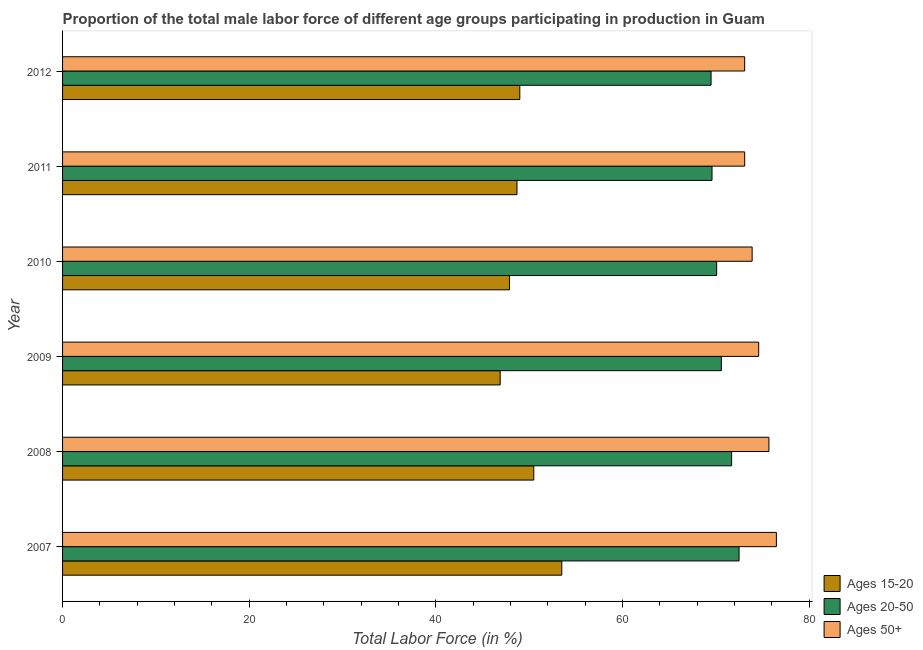How many groups of bars are there?
Your answer should be very brief. 6. Are the number of bars per tick equal to the number of legend labels?
Keep it short and to the point. Yes. Are the number of bars on each tick of the Y-axis equal?
Your answer should be very brief. Yes. How many bars are there on the 6th tick from the top?
Give a very brief answer. 3. How many bars are there on the 3rd tick from the bottom?
Make the answer very short. 3. What is the label of the 6th group of bars from the top?
Ensure brevity in your answer.  2007. In how many cases, is the number of bars for a given year not equal to the number of legend labels?
Offer a terse response. 0. What is the percentage of male labor force within the age group 15-20 in 2011?
Ensure brevity in your answer.  48.7. Across all years, what is the maximum percentage of male labor force above age 50?
Make the answer very short. 76.5. Across all years, what is the minimum percentage of male labor force within the age group 15-20?
Offer a terse response. 46.9. In which year was the percentage of male labor force within the age group 15-20 maximum?
Keep it short and to the point. 2007. What is the total percentage of male labor force above age 50 in the graph?
Your answer should be very brief. 446.9. What is the difference between the percentage of male labor force within the age group 20-50 in 2009 and the percentage of male labor force above age 50 in 2011?
Keep it short and to the point. -2.5. What is the average percentage of male labor force within the age group 20-50 per year?
Offer a very short reply. 70.67. In the year 2012, what is the difference between the percentage of male labor force within the age group 15-20 and percentage of male labor force within the age group 20-50?
Keep it short and to the point. -20.5. What is the ratio of the percentage of male labor force within the age group 20-50 in 2010 to that in 2011?
Provide a succinct answer. 1.01. Is the percentage of male labor force within the age group 15-20 in 2007 less than that in 2011?
Keep it short and to the point. No. Is the sum of the percentage of male labor force within the age group 15-20 in 2008 and 2010 greater than the maximum percentage of male labor force above age 50 across all years?
Your answer should be very brief. Yes. What does the 1st bar from the top in 2011 represents?
Your response must be concise. Ages 50+. What does the 3rd bar from the bottom in 2009 represents?
Ensure brevity in your answer.  Ages 50+. Is it the case that in every year, the sum of the percentage of male labor force within the age group 15-20 and percentage of male labor force within the age group 20-50 is greater than the percentage of male labor force above age 50?
Ensure brevity in your answer.  Yes. Are all the bars in the graph horizontal?
Make the answer very short. Yes. What is the difference between two consecutive major ticks on the X-axis?
Your response must be concise. 20. Are the values on the major ticks of X-axis written in scientific E-notation?
Make the answer very short. No. How many legend labels are there?
Keep it short and to the point. 3. How are the legend labels stacked?
Your answer should be compact. Vertical. What is the title of the graph?
Your answer should be very brief. Proportion of the total male labor force of different age groups participating in production in Guam. What is the Total Labor Force (in %) in Ages 15-20 in 2007?
Offer a very short reply. 53.5. What is the Total Labor Force (in %) of Ages 20-50 in 2007?
Offer a very short reply. 72.5. What is the Total Labor Force (in %) of Ages 50+ in 2007?
Provide a short and direct response. 76.5. What is the Total Labor Force (in %) in Ages 15-20 in 2008?
Offer a terse response. 50.5. What is the Total Labor Force (in %) of Ages 20-50 in 2008?
Provide a short and direct response. 71.7. What is the Total Labor Force (in %) in Ages 50+ in 2008?
Ensure brevity in your answer.  75.7. What is the Total Labor Force (in %) in Ages 15-20 in 2009?
Your response must be concise. 46.9. What is the Total Labor Force (in %) of Ages 20-50 in 2009?
Offer a terse response. 70.6. What is the Total Labor Force (in %) of Ages 50+ in 2009?
Your answer should be very brief. 74.6. What is the Total Labor Force (in %) in Ages 15-20 in 2010?
Offer a terse response. 47.9. What is the Total Labor Force (in %) of Ages 20-50 in 2010?
Keep it short and to the point. 70.1. What is the Total Labor Force (in %) of Ages 50+ in 2010?
Offer a very short reply. 73.9. What is the Total Labor Force (in %) of Ages 15-20 in 2011?
Provide a short and direct response. 48.7. What is the Total Labor Force (in %) of Ages 20-50 in 2011?
Give a very brief answer. 69.6. What is the Total Labor Force (in %) in Ages 50+ in 2011?
Your answer should be compact. 73.1. What is the Total Labor Force (in %) of Ages 15-20 in 2012?
Make the answer very short. 49. What is the Total Labor Force (in %) in Ages 20-50 in 2012?
Your answer should be very brief. 69.5. What is the Total Labor Force (in %) in Ages 50+ in 2012?
Provide a short and direct response. 73.1. Across all years, what is the maximum Total Labor Force (in %) of Ages 15-20?
Make the answer very short. 53.5. Across all years, what is the maximum Total Labor Force (in %) of Ages 20-50?
Your response must be concise. 72.5. Across all years, what is the maximum Total Labor Force (in %) in Ages 50+?
Provide a succinct answer. 76.5. Across all years, what is the minimum Total Labor Force (in %) in Ages 15-20?
Offer a very short reply. 46.9. Across all years, what is the minimum Total Labor Force (in %) in Ages 20-50?
Keep it short and to the point. 69.5. Across all years, what is the minimum Total Labor Force (in %) of Ages 50+?
Provide a succinct answer. 73.1. What is the total Total Labor Force (in %) of Ages 15-20 in the graph?
Make the answer very short. 296.5. What is the total Total Labor Force (in %) of Ages 20-50 in the graph?
Ensure brevity in your answer.  424. What is the total Total Labor Force (in %) of Ages 50+ in the graph?
Your response must be concise. 446.9. What is the difference between the Total Labor Force (in %) in Ages 50+ in 2007 and that in 2008?
Offer a very short reply. 0.8. What is the difference between the Total Labor Force (in %) in Ages 50+ in 2007 and that in 2009?
Offer a terse response. 1.9. What is the difference between the Total Labor Force (in %) in Ages 15-20 in 2007 and that in 2011?
Make the answer very short. 4.8. What is the difference between the Total Labor Force (in %) in Ages 20-50 in 2007 and that in 2012?
Provide a short and direct response. 3. What is the difference between the Total Labor Force (in %) of Ages 50+ in 2007 and that in 2012?
Offer a terse response. 3.4. What is the difference between the Total Labor Force (in %) of Ages 15-20 in 2008 and that in 2009?
Give a very brief answer. 3.6. What is the difference between the Total Labor Force (in %) in Ages 20-50 in 2008 and that in 2009?
Your answer should be very brief. 1.1. What is the difference between the Total Labor Force (in %) of Ages 50+ in 2008 and that in 2009?
Your answer should be compact. 1.1. What is the difference between the Total Labor Force (in %) in Ages 20-50 in 2008 and that in 2010?
Provide a succinct answer. 1.6. What is the difference between the Total Labor Force (in %) in Ages 15-20 in 2008 and that in 2011?
Offer a very short reply. 1.8. What is the difference between the Total Labor Force (in %) in Ages 15-20 in 2008 and that in 2012?
Give a very brief answer. 1.5. What is the difference between the Total Labor Force (in %) of Ages 20-50 in 2009 and that in 2010?
Your answer should be compact. 0.5. What is the difference between the Total Labor Force (in %) of Ages 15-20 in 2009 and that in 2011?
Give a very brief answer. -1.8. What is the difference between the Total Labor Force (in %) in Ages 50+ in 2009 and that in 2011?
Make the answer very short. 1.5. What is the difference between the Total Labor Force (in %) of Ages 15-20 in 2009 and that in 2012?
Ensure brevity in your answer.  -2.1. What is the difference between the Total Labor Force (in %) in Ages 20-50 in 2009 and that in 2012?
Your answer should be very brief. 1.1. What is the difference between the Total Labor Force (in %) in Ages 50+ in 2009 and that in 2012?
Give a very brief answer. 1.5. What is the difference between the Total Labor Force (in %) in Ages 20-50 in 2010 and that in 2012?
Your response must be concise. 0.6. What is the difference between the Total Labor Force (in %) of Ages 20-50 in 2011 and that in 2012?
Provide a short and direct response. 0.1. What is the difference between the Total Labor Force (in %) in Ages 50+ in 2011 and that in 2012?
Make the answer very short. 0. What is the difference between the Total Labor Force (in %) in Ages 15-20 in 2007 and the Total Labor Force (in %) in Ages 20-50 in 2008?
Provide a succinct answer. -18.2. What is the difference between the Total Labor Force (in %) in Ages 15-20 in 2007 and the Total Labor Force (in %) in Ages 50+ in 2008?
Make the answer very short. -22.2. What is the difference between the Total Labor Force (in %) of Ages 20-50 in 2007 and the Total Labor Force (in %) of Ages 50+ in 2008?
Give a very brief answer. -3.2. What is the difference between the Total Labor Force (in %) of Ages 15-20 in 2007 and the Total Labor Force (in %) of Ages 20-50 in 2009?
Offer a very short reply. -17.1. What is the difference between the Total Labor Force (in %) of Ages 15-20 in 2007 and the Total Labor Force (in %) of Ages 50+ in 2009?
Your answer should be compact. -21.1. What is the difference between the Total Labor Force (in %) in Ages 15-20 in 2007 and the Total Labor Force (in %) in Ages 20-50 in 2010?
Provide a short and direct response. -16.6. What is the difference between the Total Labor Force (in %) of Ages 15-20 in 2007 and the Total Labor Force (in %) of Ages 50+ in 2010?
Make the answer very short. -20.4. What is the difference between the Total Labor Force (in %) in Ages 20-50 in 2007 and the Total Labor Force (in %) in Ages 50+ in 2010?
Keep it short and to the point. -1.4. What is the difference between the Total Labor Force (in %) in Ages 15-20 in 2007 and the Total Labor Force (in %) in Ages 20-50 in 2011?
Your response must be concise. -16.1. What is the difference between the Total Labor Force (in %) in Ages 15-20 in 2007 and the Total Labor Force (in %) in Ages 50+ in 2011?
Keep it short and to the point. -19.6. What is the difference between the Total Labor Force (in %) in Ages 20-50 in 2007 and the Total Labor Force (in %) in Ages 50+ in 2011?
Provide a short and direct response. -0.6. What is the difference between the Total Labor Force (in %) in Ages 15-20 in 2007 and the Total Labor Force (in %) in Ages 50+ in 2012?
Ensure brevity in your answer.  -19.6. What is the difference between the Total Labor Force (in %) of Ages 20-50 in 2007 and the Total Labor Force (in %) of Ages 50+ in 2012?
Your answer should be compact. -0.6. What is the difference between the Total Labor Force (in %) of Ages 15-20 in 2008 and the Total Labor Force (in %) of Ages 20-50 in 2009?
Keep it short and to the point. -20.1. What is the difference between the Total Labor Force (in %) of Ages 15-20 in 2008 and the Total Labor Force (in %) of Ages 50+ in 2009?
Offer a terse response. -24.1. What is the difference between the Total Labor Force (in %) in Ages 20-50 in 2008 and the Total Labor Force (in %) in Ages 50+ in 2009?
Offer a very short reply. -2.9. What is the difference between the Total Labor Force (in %) in Ages 15-20 in 2008 and the Total Labor Force (in %) in Ages 20-50 in 2010?
Your answer should be compact. -19.6. What is the difference between the Total Labor Force (in %) of Ages 15-20 in 2008 and the Total Labor Force (in %) of Ages 50+ in 2010?
Your answer should be compact. -23.4. What is the difference between the Total Labor Force (in %) of Ages 20-50 in 2008 and the Total Labor Force (in %) of Ages 50+ in 2010?
Give a very brief answer. -2.2. What is the difference between the Total Labor Force (in %) of Ages 15-20 in 2008 and the Total Labor Force (in %) of Ages 20-50 in 2011?
Offer a very short reply. -19.1. What is the difference between the Total Labor Force (in %) in Ages 15-20 in 2008 and the Total Labor Force (in %) in Ages 50+ in 2011?
Provide a short and direct response. -22.6. What is the difference between the Total Labor Force (in %) of Ages 20-50 in 2008 and the Total Labor Force (in %) of Ages 50+ in 2011?
Offer a terse response. -1.4. What is the difference between the Total Labor Force (in %) in Ages 15-20 in 2008 and the Total Labor Force (in %) in Ages 20-50 in 2012?
Give a very brief answer. -19. What is the difference between the Total Labor Force (in %) in Ages 15-20 in 2008 and the Total Labor Force (in %) in Ages 50+ in 2012?
Keep it short and to the point. -22.6. What is the difference between the Total Labor Force (in %) of Ages 20-50 in 2008 and the Total Labor Force (in %) of Ages 50+ in 2012?
Offer a very short reply. -1.4. What is the difference between the Total Labor Force (in %) in Ages 15-20 in 2009 and the Total Labor Force (in %) in Ages 20-50 in 2010?
Provide a short and direct response. -23.2. What is the difference between the Total Labor Force (in %) of Ages 20-50 in 2009 and the Total Labor Force (in %) of Ages 50+ in 2010?
Offer a terse response. -3.3. What is the difference between the Total Labor Force (in %) of Ages 15-20 in 2009 and the Total Labor Force (in %) of Ages 20-50 in 2011?
Your answer should be very brief. -22.7. What is the difference between the Total Labor Force (in %) in Ages 15-20 in 2009 and the Total Labor Force (in %) in Ages 50+ in 2011?
Give a very brief answer. -26.2. What is the difference between the Total Labor Force (in %) of Ages 15-20 in 2009 and the Total Labor Force (in %) of Ages 20-50 in 2012?
Make the answer very short. -22.6. What is the difference between the Total Labor Force (in %) in Ages 15-20 in 2009 and the Total Labor Force (in %) in Ages 50+ in 2012?
Ensure brevity in your answer.  -26.2. What is the difference between the Total Labor Force (in %) of Ages 15-20 in 2010 and the Total Labor Force (in %) of Ages 20-50 in 2011?
Your response must be concise. -21.7. What is the difference between the Total Labor Force (in %) in Ages 15-20 in 2010 and the Total Labor Force (in %) in Ages 50+ in 2011?
Make the answer very short. -25.2. What is the difference between the Total Labor Force (in %) in Ages 15-20 in 2010 and the Total Labor Force (in %) in Ages 20-50 in 2012?
Ensure brevity in your answer.  -21.6. What is the difference between the Total Labor Force (in %) in Ages 15-20 in 2010 and the Total Labor Force (in %) in Ages 50+ in 2012?
Provide a short and direct response. -25.2. What is the difference between the Total Labor Force (in %) of Ages 15-20 in 2011 and the Total Labor Force (in %) of Ages 20-50 in 2012?
Your answer should be very brief. -20.8. What is the difference between the Total Labor Force (in %) in Ages 15-20 in 2011 and the Total Labor Force (in %) in Ages 50+ in 2012?
Offer a terse response. -24.4. What is the difference between the Total Labor Force (in %) in Ages 20-50 in 2011 and the Total Labor Force (in %) in Ages 50+ in 2012?
Provide a succinct answer. -3.5. What is the average Total Labor Force (in %) of Ages 15-20 per year?
Provide a succinct answer. 49.42. What is the average Total Labor Force (in %) in Ages 20-50 per year?
Provide a short and direct response. 70.67. What is the average Total Labor Force (in %) of Ages 50+ per year?
Your answer should be compact. 74.48. In the year 2007, what is the difference between the Total Labor Force (in %) of Ages 15-20 and Total Labor Force (in %) of Ages 50+?
Keep it short and to the point. -23. In the year 2008, what is the difference between the Total Labor Force (in %) of Ages 15-20 and Total Labor Force (in %) of Ages 20-50?
Make the answer very short. -21.2. In the year 2008, what is the difference between the Total Labor Force (in %) in Ages 15-20 and Total Labor Force (in %) in Ages 50+?
Make the answer very short. -25.2. In the year 2009, what is the difference between the Total Labor Force (in %) in Ages 15-20 and Total Labor Force (in %) in Ages 20-50?
Make the answer very short. -23.7. In the year 2009, what is the difference between the Total Labor Force (in %) in Ages 15-20 and Total Labor Force (in %) in Ages 50+?
Offer a terse response. -27.7. In the year 2009, what is the difference between the Total Labor Force (in %) of Ages 20-50 and Total Labor Force (in %) of Ages 50+?
Your answer should be compact. -4. In the year 2010, what is the difference between the Total Labor Force (in %) of Ages 15-20 and Total Labor Force (in %) of Ages 20-50?
Make the answer very short. -22.2. In the year 2010, what is the difference between the Total Labor Force (in %) of Ages 20-50 and Total Labor Force (in %) of Ages 50+?
Your answer should be very brief. -3.8. In the year 2011, what is the difference between the Total Labor Force (in %) of Ages 15-20 and Total Labor Force (in %) of Ages 20-50?
Provide a succinct answer. -20.9. In the year 2011, what is the difference between the Total Labor Force (in %) in Ages 15-20 and Total Labor Force (in %) in Ages 50+?
Keep it short and to the point. -24.4. In the year 2012, what is the difference between the Total Labor Force (in %) of Ages 15-20 and Total Labor Force (in %) of Ages 20-50?
Make the answer very short. -20.5. In the year 2012, what is the difference between the Total Labor Force (in %) in Ages 15-20 and Total Labor Force (in %) in Ages 50+?
Give a very brief answer. -24.1. What is the ratio of the Total Labor Force (in %) of Ages 15-20 in 2007 to that in 2008?
Provide a succinct answer. 1.06. What is the ratio of the Total Labor Force (in %) in Ages 20-50 in 2007 to that in 2008?
Ensure brevity in your answer.  1.01. What is the ratio of the Total Labor Force (in %) of Ages 50+ in 2007 to that in 2008?
Give a very brief answer. 1.01. What is the ratio of the Total Labor Force (in %) in Ages 15-20 in 2007 to that in 2009?
Provide a short and direct response. 1.14. What is the ratio of the Total Labor Force (in %) of Ages 20-50 in 2007 to that in 2009?
Keep it short and to the point. 1.03. What is the ratio of the Total Labor Force (in %) in Ages 50+ in 2007 to that in 2009?
Provide a succinct answer. 1.03. What is the ratio of the Total Labor Force (in %) in Ages 15-20 in 2007 to that in 2010?
Keep it short and to the point. 1.12. What is the ratio of the Total Labor Force (in %) of Ages 20-50 in 2007 to that in 2010?
Ensure brevity in your answer.  1.03. What is the ratio of the Total Labor Force (in %) of Ages 50+ in 2007 to that in 2010?
Ensure brevity in your answer.  1.04. What is the ratio of the Total Labor Force (in %) in Ages 15-20 in 2007 to that in 2011?
Offer a very short reply. 1.1. What is the ratio of the Total Labor Force (in %) in Ages 20-50 in 2007 to that in 2011?
Offer a terse response. 1.04. What is the ratio of the Total Labor Force (in %) of Ages 50+ in 2007 to that in 2011?
Ensure brevity in your answer.  1.05. What is the ratio of the Total Labor Force (in %) of Ages 15-20 in 2007 to that in 2012?
Offer a terse response. 1.09. What is the ratio of the Total Labor Force (in %) of Ages 20-50 in 2007 to that in 2012?
Provide a short and direct response. 1.04. What is the ratio of the Total Labor Force (in %) in Ages 50+ in 2007 to that in 2012?
Provide a short and direct response. 1.05. What is the ratio of the Total Labor Force (in %) of Ages 15-20 in 2008 to that in 2009?
Offer a very short reply. 1.08. What is the ratio of the Total Labor Force (in %) in Ages 20-50 in 2008 to that in 2009?
Provide a short and direct response. 1.02. What is the ratio of the Total Labor Force (in %) of Ages 50+ in 2008 to that in 2009?
Make the answer very short. 1.01. What is the ratio of the Total Labor Force (in %) in Ages 15-20 in 2008 to that in 2010?
Your response must be concise. 1.05. What is the ratio of the Total Labor Force (in %) in Ages 20-50 in 2008 to that in 2010?
Offer a very short reply. 1.02. What is the ratio of the Total Labor Force (in %) in Ages 50+ in 2008 to that in 2010?
Your answer should be compact. 1.02. What is the ratio of the Total Labor Force (in %) in Ages 15-20 in 2008 to that in 2011?
Offer a terse response. 1.04. What is the ratio of the Total Labor Force (in %) of Ages 20-50 in 2008 to that in 2011?
Keep it short and to the point. 1.03. What is the ratio of the Total Labor Force (in %) of Ages 50+ in 2008 to that in 2011?
Make the answer very short. 1.04. What is the ratio of the Total Labor Force (in %) in Ages 15-20 in 2008 to that in 2012?
Give a very brief answer. 1.03. What is the ratio of the Total Labor Force (in %) of Ages 20-50 in 2008 to that in 2012?
Offer a very short reply. 1.03. What is the ratio of the Total Labor Force (in %) in Ages 50+ in 2008 to that in 2012?
Provide a succinct answer. 1.04. What is the ratio of the Total Labor Force (in %) of Ages 15-20 in 2009 to that in 2010?
Provide a succinct answer. 0.98. What is the ratio of the Total Labor Force (in %) in Ages 20-50 in 2009 to that in 2010?
Your answer should be very brief. 1.01. What is the ratio of the Total Labor Force (in %) in Ages 50+ in 2009 to that in 2010?
Your answer should be compact. 1.01. What is the ratio of the Total Labor Force (in %) of Ages 15-20 in 2009 to that in 2011?
Keep it short and to the point. 0.96. What is the ratio of the Total Labor Force (in %) of Ages 20-50 in 2009 to that in 2011?
Offer a terse response. 1.01. What is the ratio of the Total Labor Force (in %) of Ages 50+ in 2009 to that in 2011?
Your answer should be compact. 1.02. What is the ratio of the Total Labor Force (in %) of Ages 15-20 in 2009 to that in 2012?
Your answer should be compact. 0.96. What is the ratio of the Total Labor Force (in %) in Ages 20-50 in 2009 to that in 2012?
Your response must be concise. 1.02. What is the ratio of the Total Labor Force (in %) in Ages 50+ in 2009 to that in 2012?
Offer a very short reply. 1.02. What is the ratio of the Total Labor Force (in %) of Ages 15-20 in 2010 to that in 2011?
Your answer should be very brief. 0.98. What is the ratio of the Total Labor Force (in %) in Ages 20-50 in 2010 to that in 2011?
Ensure brevity in your answer.  1.01. What is the ratio of the Total Labor Force (in %) of Ages 50+ in 2010 to that in 2011?
Your response must be concise. 1.01. What is the ratio of the Total Labor Force (in %) in Ages 15-20 in 2010 to that in 2012?
Offer a very short reply. 0.98. What is the ratio of the Total Labor Force (in %) in Ages 20-50 in 2010 to that in 2012?
Your answer should be very brief. 1.01. What is the ratio of the Total Labor Force (in %) of Ages 50+ in 2010 to that in 2012?
Give a very brief answer. 1.01. What is the ratio of the Total Labor Force (in %) of Ages 20-50 in 2011 to that in 2012?
Offer a terse response. 1. What is the ratio of the Total Labor Force (in %) of Ages 50+ in 2011 to that in 2012?
Your response must be concise. 1. What is the difference between the highest and the second highest Total Labor Force (in %) of Ages 15-20?
Make the answer very short. 3. What is the difference between the highest and the lowest Total Labor Force (in %) of Ages 20-50?
Offer a very short reply. 3. What is the difference between the highest and the lowest Total Labor Force (in %) in Ages 50+?
Make the answer very short. 3.4. 